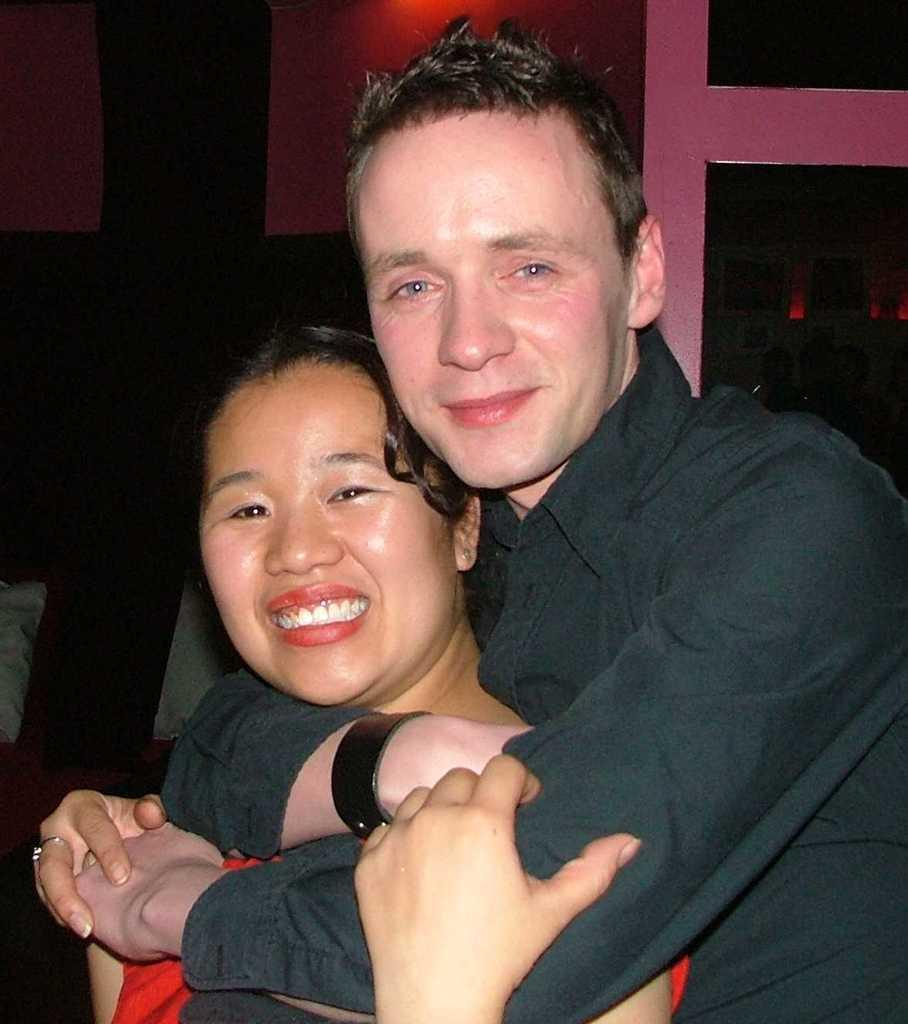How many people are in the image? There are two people in the image, a man and a woman. What is the color of the background in the image? The background of the image is dark. What type of relation do the man and woman have in the image? There is no information provided about the relationship between the man and woman in the image. Can you tell me how many times the man jumps in the image? There is no indication of anyone jumping in the image. 